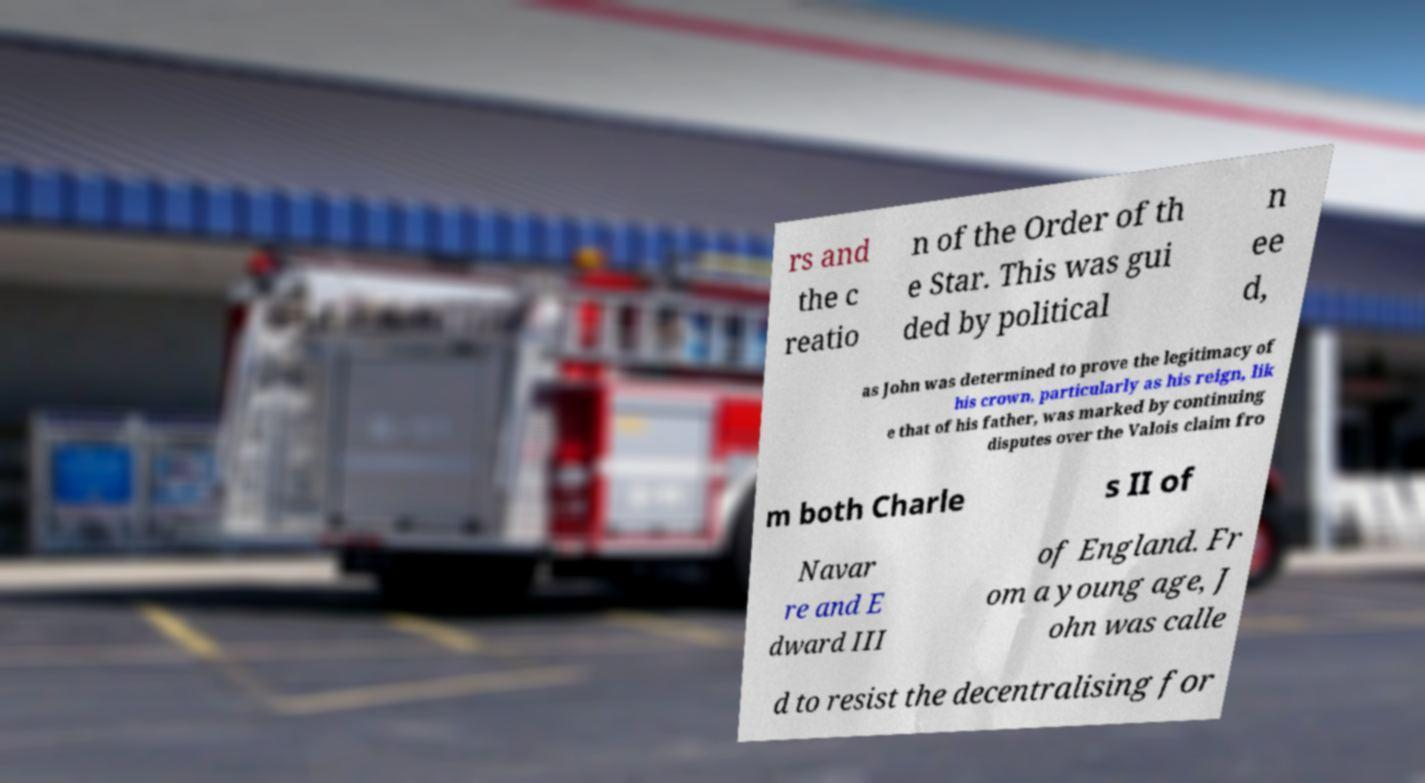For documentation purposes, I need the text within this image transcribed. Could you provide that? rs and the c reatio n of the Order of th e Star. This was gui ded by political n ee d, as John was determined to prove the legitimacy of his crown, particularly as his reign, lik e that of his father, was marked by continuing disputes over the Valois claim fro m both Charle s II of Navar re and E dward III of England. Fr om a young age, J ohn was calle d to resist the decentralising for 